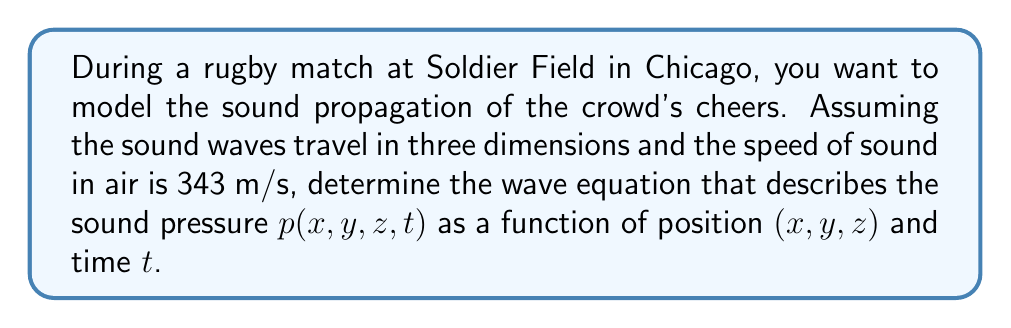Solve this math problem. To determine the wave equation for sound propagation in three dimensions, we need to follow these steps:

1) The general form of the wave equation in three dimensions is:

   $$\frac{\partial^2 p}{\partial x^2} + \frac{\partial^2 p}{\partial y^2} + \frac{\partial^2 p}{\partial z^2} = \frac{1}{c^2} \frac{\partial^2 p}{\partial t^2}$$

   where $p$ is the sound pressure, and $c$ is the speed of sound.

2) We're given that the speed of sound in air is 343 m/s. Let's substitute this value:

   $$\frac{\partial^2 p}{\partial x^2} + \frac{\partial^2 p}{\partial y^2} + \frac{\partial^2 p}{\partial z^2} = \frac{1}{(343 \text{ m/s})^2} \frac{\partial^2 p}{\partial t^2}$$

3) Simplify the right-hand side:

   $$\frac{\partial^2 p}{\partial x^2} + \frac{\partial^2 p}{\partial y^2} + \frac{\partial^2 p}{\partial z^2} = \frac{1}{117649 \text{ m}^2/\text{s}^2} \frac{\partial^2 p}{\partial t^2}$$

4) We can write this more compactly using the Laplacian operator $\nabla^2$:

   $$\nabla^2 p = \frac{1}{117649 \text{ m}^2/\text{s}^2} \frac{\partial^2 p}{\partial t^2}$$

This is the wave equation describing the sound propagation of the crowd's cheers during the rugby match at Soldier Field.
Answer: The wave equation for sound propagation during the rugby match is:

$$\nabla^2 p = \frac{1}{117649 \text{ m}^2/\text{s}^2} \frac{\partial^2 p}{\partial t^2}$$

where $p = p(x,y,z,t)$ is the sound pressure, and $\nabla^2 = \frac{\partial^2}{\partial x^2} + \frac{\partial^2}{\partial y^2} + \frac{\partial^2}{\partial z^2}$ is the Laplacian operator. 